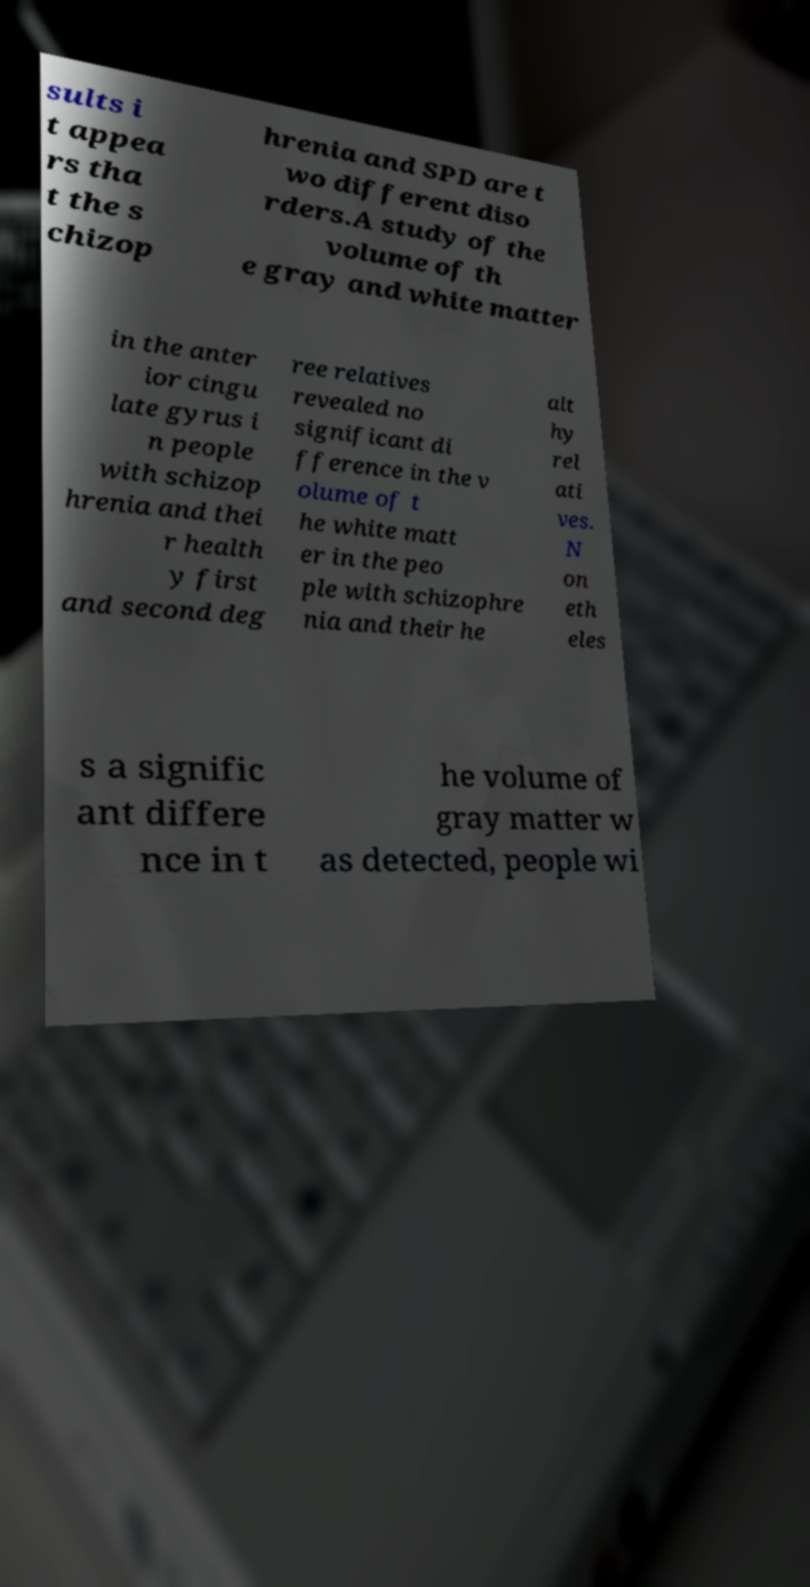Please identify and transcribe the text found in this image. sults i t appea rs tha t the s chizop hrenia and SPD are t wo different diso rders.A study of the volume of th e gray and white matter in the anter ior cingu late gyrus i n people with schizop hrenia and thei r health y first and second deg ree relatives revealed no significant di fference in the v olume of t he white matt er in the peo ple with schizophre nia and their he alt hy rel ati ves. N on eth eles s a signific ant differe nce in t he volume of gray matter w as detected, people wi 